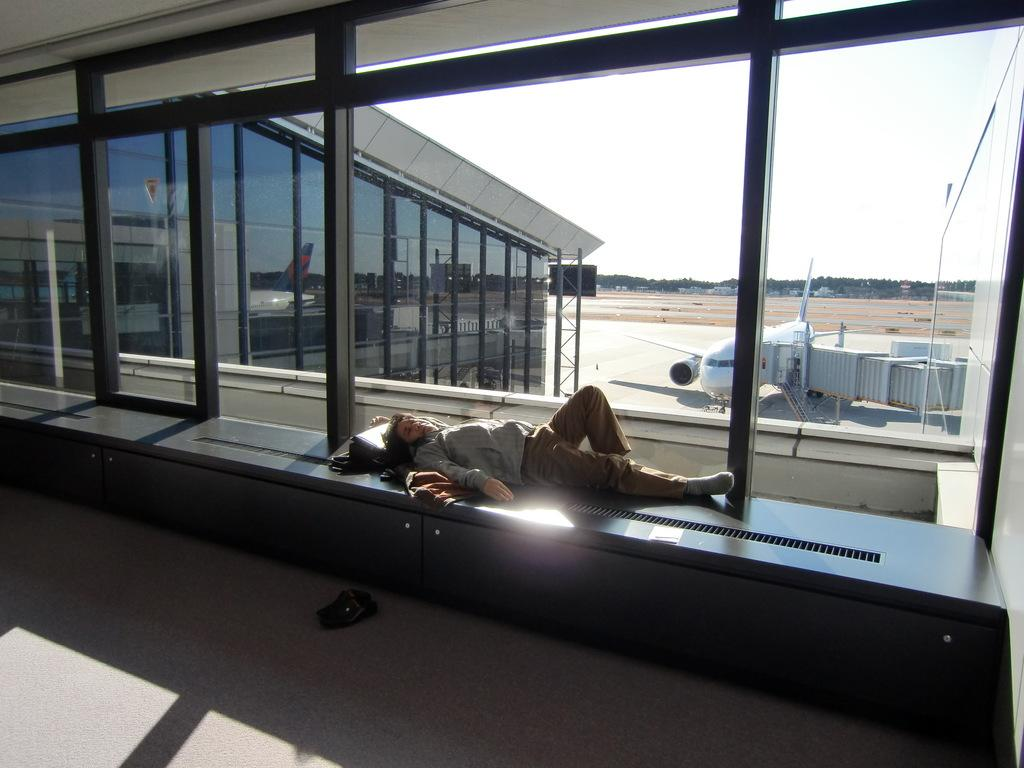What is the person in the image doing? The person is laying on the path in the image. What is located beside the path? There is a room beside the path. What can be seen in the sky in the image? There is a plane visible in the image. What type of vegetation is present in the image? There are trees and plants in the image. How many dimes can be seen on the person laying on the path? There are no dimes visible on the person laying on the path in the image. What type of leaf is present on the person laying on the path? There are no leaves visible on the person laying on the path in the image. 